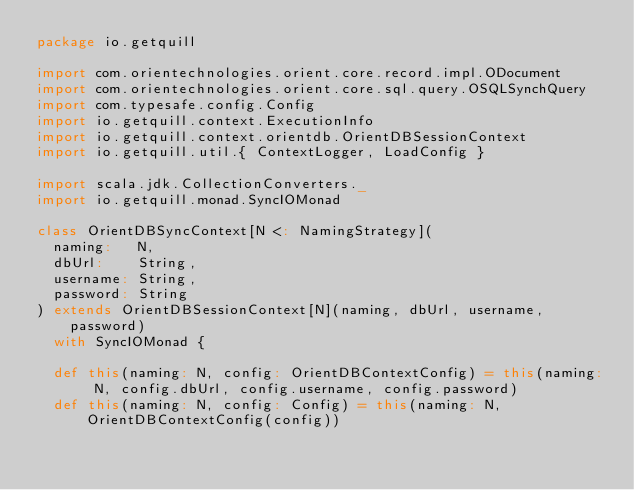Convert code to text. <code><loc_0><loc_0><loc_500><loc_500><_Scala_>package io.getquill

import com.orientechnologies.orient.core.record.impl.ODocument
import com.orientechnologies.orient.core.sql.query.OSQLSynchQuery
import com.typesafe.config.Config
import io.getquill.context.ExecutionInfo
import io.getquill.context.orientdb.OrientDBSessionContext
import io.getquill.util.{ ContextLogger, LoadConfig }

import scala.jdk.CollectionConverters._
import io.getquill.monad.SyncIOMonad

class OrientDBSyncContext[N <: NamingStrategy](
  naming:   N,
  dbUrl:    String,
  username: String,
  password: String
) extends OrientDBSessionContext[N](naming, dbUrl, username, password)
  with SyncIOMonad {

  def this(naming: N, config: OrientDBContextConfig) = this(naming: N, config.dbUrl, config.username, config.password)
  def this(naming: N, config: Config) = this(naming: N, OrientDBContextConfig(config))</code> 